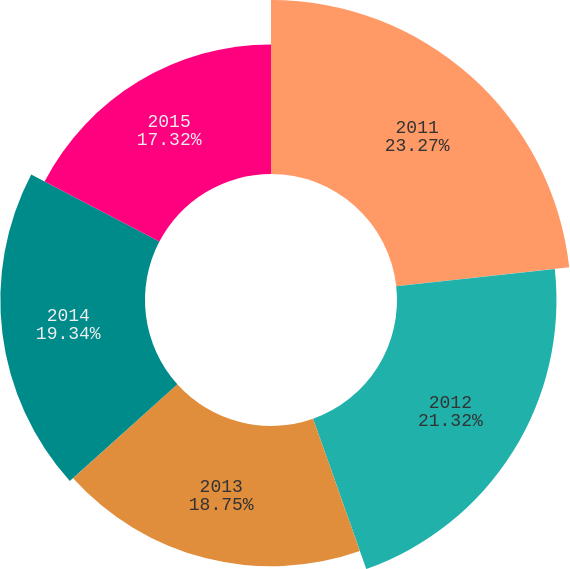<chart> <loc_0><loc_0><loc_500><loc_500><pie_chart><fcel>2011<fcel>2012<fcel>2013<fcel>2014<fcel>2015<nl><fcel>23.26%<fcel>21.32%<fcel>18.75%<fcel>19.34%<fcel>17.32%<nl></chart> 